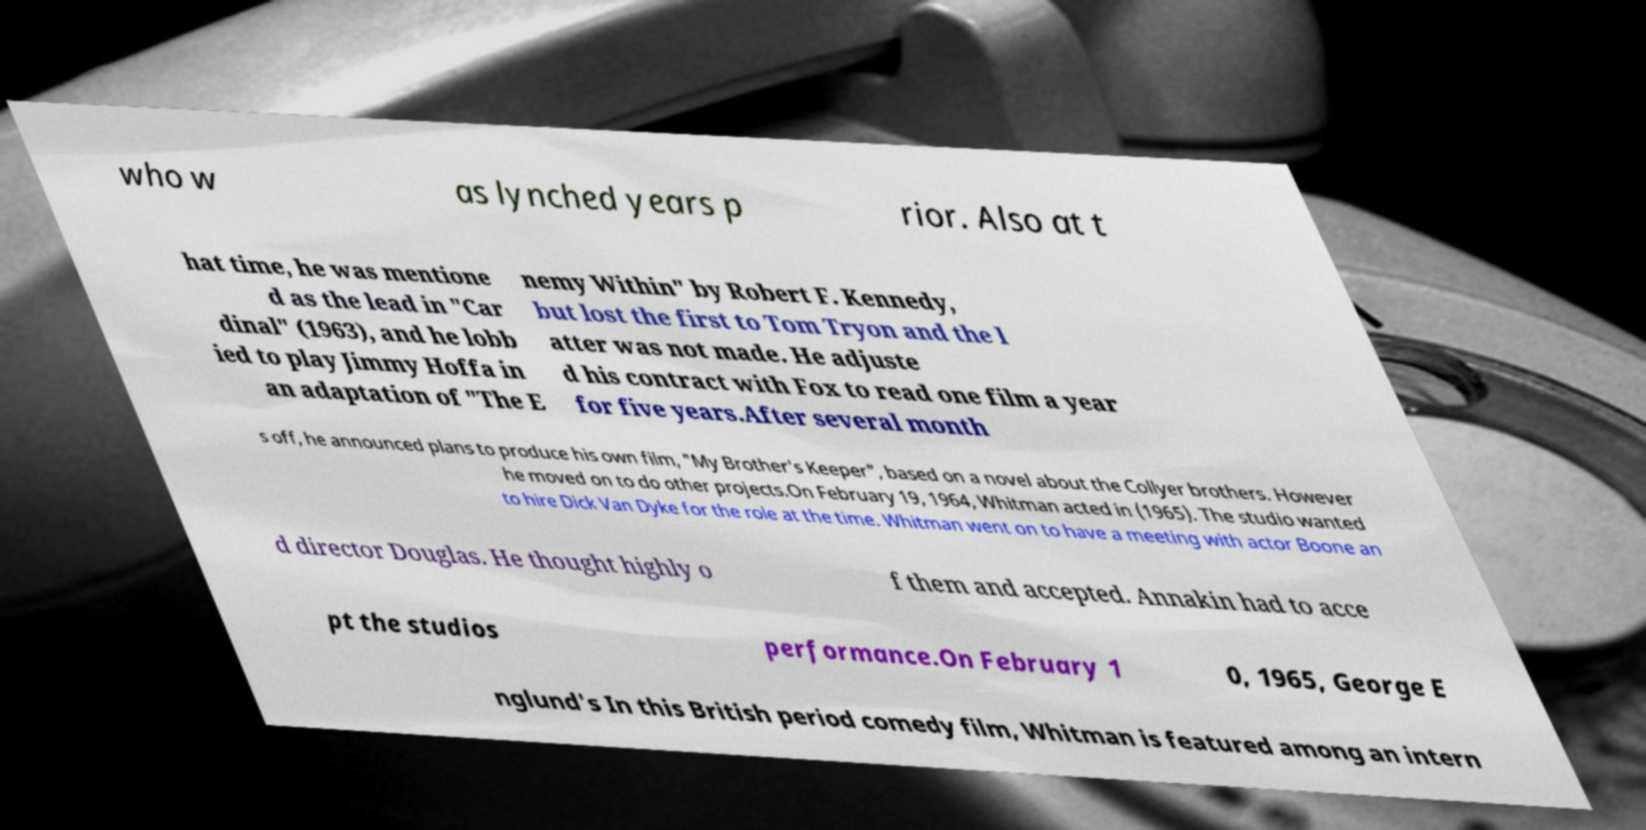I need the written content from this picture converted into text. Can you do that? who w as lynched years p rior. Also at t hat time, he was mentione d as the lead in "Car dinal" (1963), and he lobb ied to play Jimmy Hoffa in an adaptation of "The E nemy Within" by Robert F. Kennedy, but lost the first to Tom Tryon and the l atter was not made. He adjuste d his contract with Fox to read one film a year for five years.After several month s off, he announced plans to produce his own film, "My Brother's Keeper", based on a novel about the Collyer brothers. However he moved on to do other projects.On February 19, 1964, Whitman acted in (1965). The studio wanted to hire Dick Van Dyke for the role at the time. Whitman went on to have a meeting with actor Boone an d director Douglas. He thought highly o f them and accepted. Annakin had to acce pt the studios performance.On February 1 0, 1965, George E nglund's In this British period comedy film, Whitman is featured among an intern 